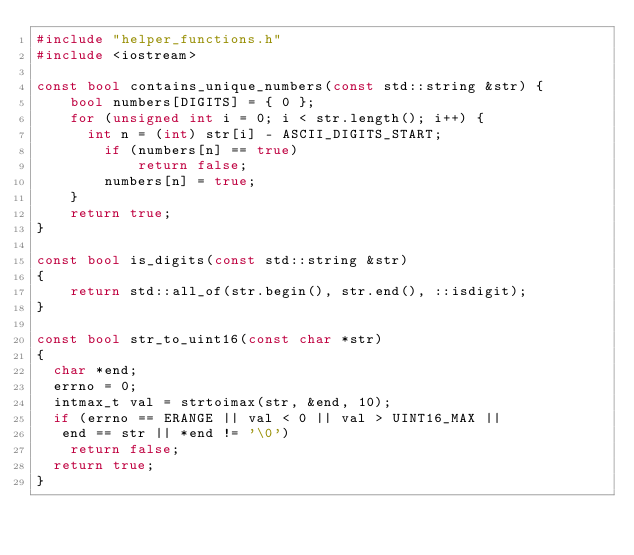Convert code to text. <code><loc_0><loc_0><loc_500><loc_500><_C++_>#include "helper_functions.h"
#include <iostream>

const bool contains_unique_numbers(const std::string &str) {
    bool numbers[DIGITS] = { 0 }; 
    for (unsigned int i = 0; i < str.length(); i++) { 
    	int n = (int) str[i] - ASCII_DIGITS_START;
        if (numbers[n] == true) 
            return false; 
        numbers[n] = true; 
    } 
    return true; 
}

const bool is_digits(const std::string &str)
{
    return std::all_of(str.begin(), str.end(), ::isdigit);
}

const bool str_to_uint16(const char *str)
{
  char *end;
  errno = 0;
  intmax_t val = strtoimax(str, &end, 10);
  if (errno == ERANGE || val < 0 || val > UINT16_MAX ||
   end == str || *end != '\0')
    return false;
  return true;
}
</code> 